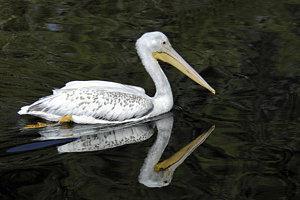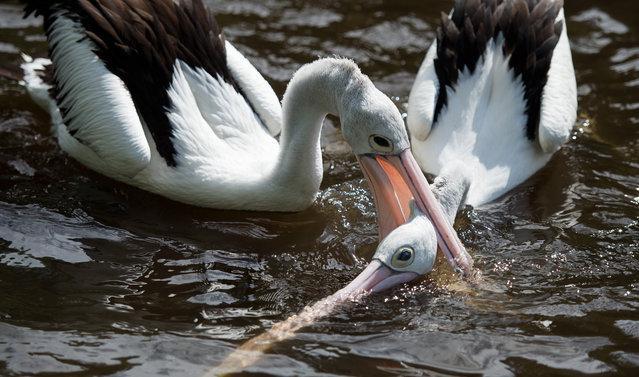The first image is the image on the left, the second image is the image on the right. Assess this claim about the two images: "there are no more then two birds in the left pic". Correct or not? Answer yes or no. Yes. The first image is the image on the left, the second image is the image on the right. For the images shown, is this caption "There are at least six pelicans." true? Answer yes or no. No. 